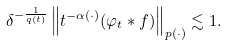<formula> <loc_0><loc_0><loc_500><loc_500>\delta ^ { - \frac { 1 } { q ( t ) } } \left \| t ^ { - \alpha ( \cdot ) } ( \varphi _ { t } \ast f ) \right \| _ { p ( \cdot ) } \lesssim 1 .</formula> 